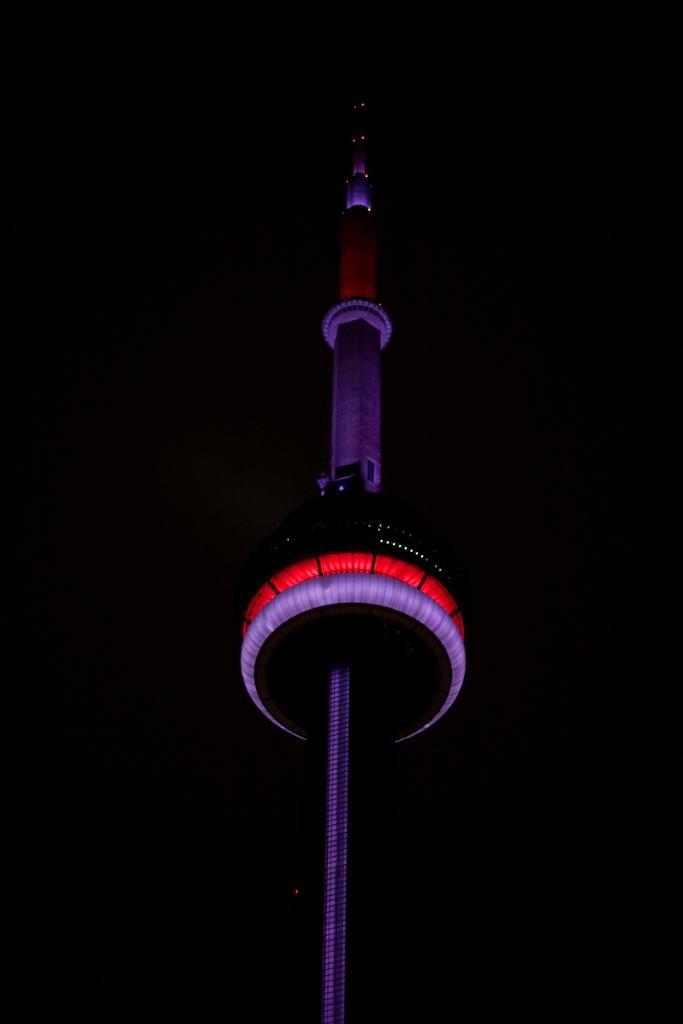What is the color of the background in the image? The background of the image is dark. What type of structures can be seen in the image? There are tall buildings in the image. What feature do the tall buildings have? The tall buildings have colorful lights. How many ladybugs can be seen sleeping on the tall buildings in the image? There are no ladybugs present in the image, and they cannot sleep on the buildings as they are not capable of such behavior. 